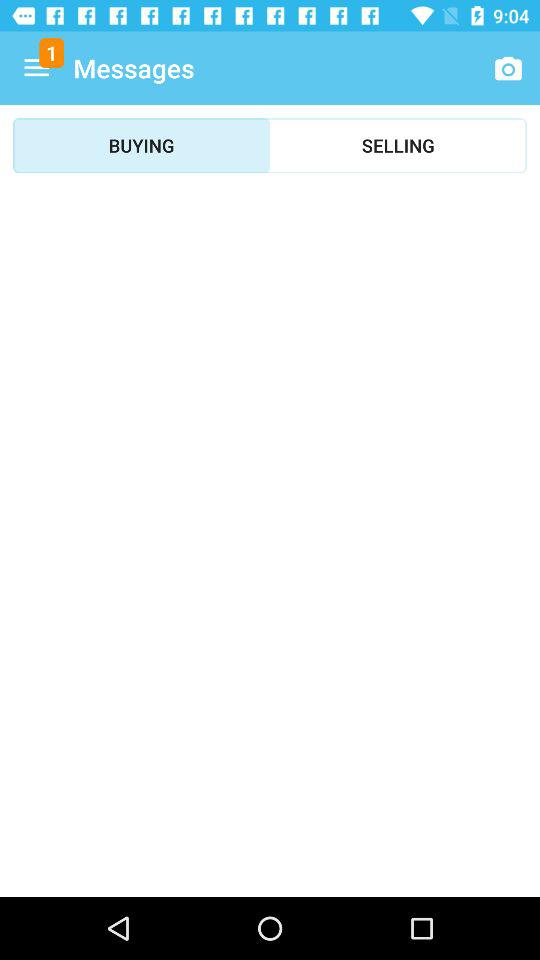Which option is selected? The selected option is "BUYING". 